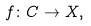Convert formula to latex. <formula><loc_0><loc_0><loc_500><loc_500>f \colon C \to X ,</formula> 